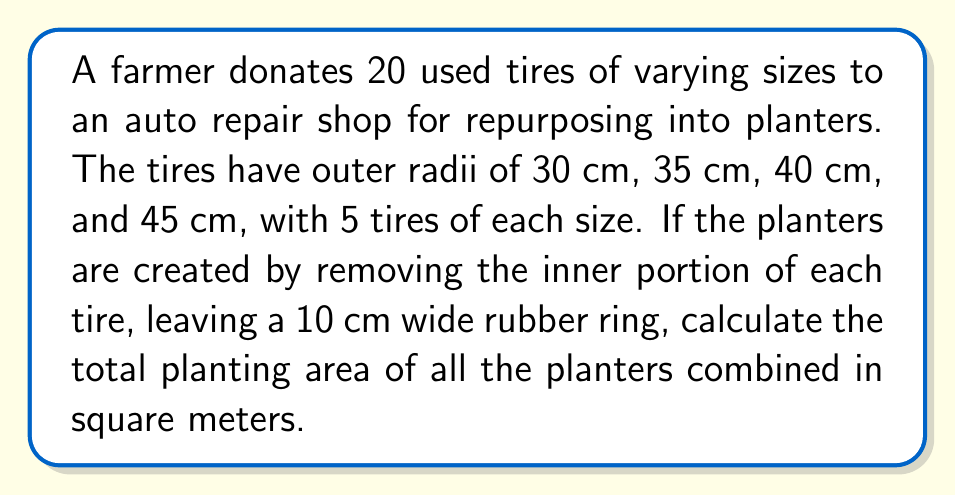Teach me how to tackle this problem. Let's approach this step-by-step:

1) First, we need to calculate the inner radius of each planter:
   - For 30 cm outer radius: $30 - 10 = 20$ cm inner radius
   - For 35 cm outer radius: $35 - 10 = 25$ cm inner radius
   - For 40 cm outer radius: $40 - 10 = 30$ cm inner radius
   - For 45 cm outer radius: $45 - 10 = 35$ cm inner radius

2) Now, we can calculate the area of each planter using the formula:
   $A = \pi(R^2 - r^2)$, where $R$ is the outer radius and $r$ is the inner radius.

3) For 30 cm outer radius planters:
   $A_1 = \pi(30^2 - 20^2) = 1600\pi$ cm²

4) For 35 cm outer radius planters:
   $A_2 = \pi(35^2 - 25^2) = 1800\pi$ cm²

5) For 40 cm outer radius planters:
   $A_3 = \pi(40^2 - 30^2) = 2000\pi$ cm²

6) For 45 cm outer radius planters:
   $A_4 = \pi(45^2 - 35^2) = 2200\pi$ cm²

7) Total area for all planters:
   $A_{total} = 5(A_1 + A_2 + A_3 + A_4)$
   $A_{total} = 5(1600\pi + 1800\pi + 2000\pi + 2200\pi)$
   $A_{total} = 5(7600\pi)$ cm²
   $A_{total} = 38000\pi$ cm²

8) Convert to square meters:
   $A_{total} = 38000\pi \times \frac{1}{10000}$ m²
   $A_{total} = 3.8\pi$ m²
Answer: $3.8\pi$ m² 